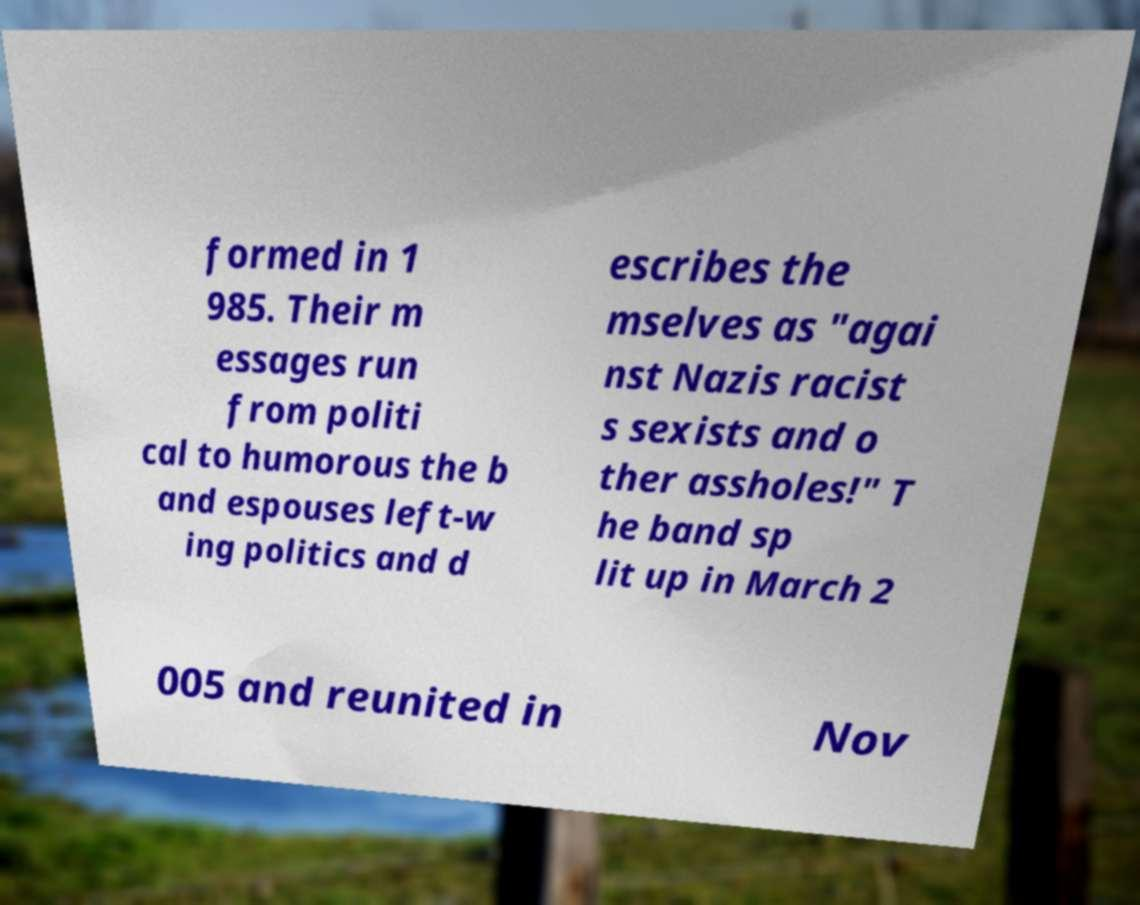For documentation purposes, I need the text within this image transcribed. Could you provide that? formed in 1 985. Their m essages run from politi cal to humorous the b and espouses left-w ing politics and d escribes the mselves as "agai nst Nazis racist s sexists and o ther assholes!" T he band sp lit up in March 2 005 and reunited in Nov 